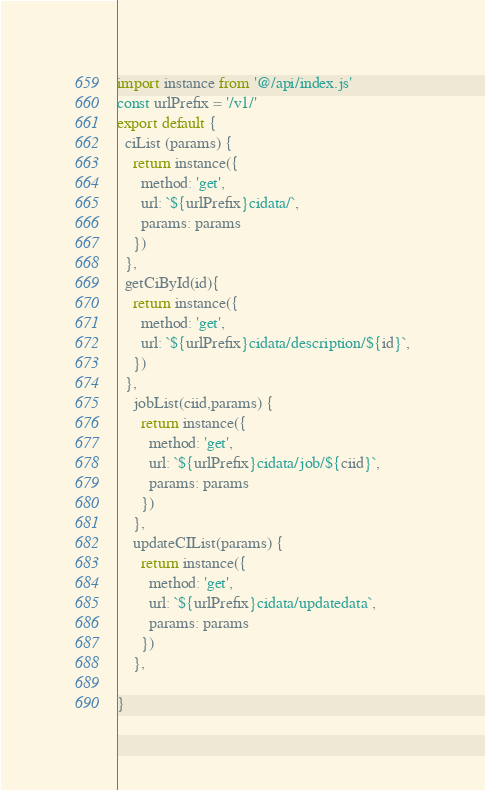Convert code to text. <code><loc_0><loc_0><loc_500><loc_500><_JavaScript_>import instance from '@/api/index.js'
const urlPrefix = '/v1/'
export default {
  ciList (params) {
    return instance({
      method: 'get',
      url: `${urlPrefix}cidata/`,
      params: params
    })
  },
  getCiById(id){
    return instance({
      method: 'get',
      url: `${urlPrefix}cidata/description/${id}`,
    })
  },
	jobList(ciid,params) {
	  return instance({
	    method: 'get',
	    url: `${urlPrefix}cidata/job/${ciid}`,
	    params: params
	  })
	},
	updateCIList(params) {
	  return instance({
	    method: 'get',
	    url: `${urlPrefix}cidata/updatedata`,
	    params: params
	  })
	},

}
</code> 